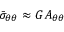<formula> <loc_0><loc_0><loc_500><loc_500>\bar { \sigma } _ { \theta \theta } \approx G A _ { \theta \theta }</formula> 